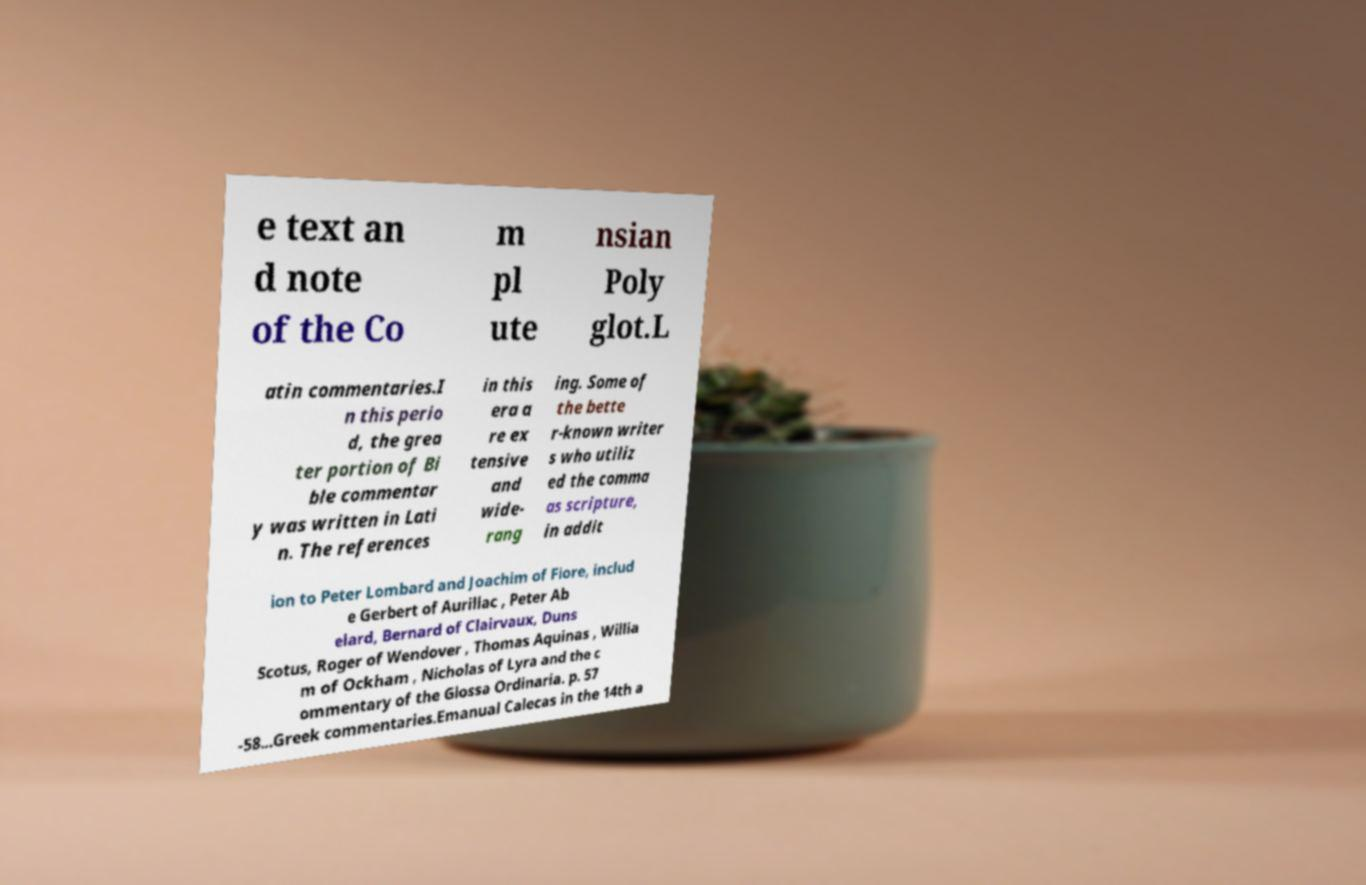Could you assist in decoding the text presented in this image and type it out clearly? e text an d note of the Co m pl ute nsian Poly glot.L atin commentaries.I n this perio d, the grea ter portion of Bi ble commentar y was written in Lati n. The references in this era a re ex tensive and wide- rang ing. Some of the bette r-known writer s who utiliz ed the comma as scripture, in addit ion to Peter Lombard and Joachim of Fiore, includ e Gerbert of Aurillac , Peter Ab elard, Bernard of Clairvaux, Duns Scotus, Roger of Wendover , Thomas Aquinas , Willia m of Ockham , Nicholas of Lyra and the c ommentary of the Glossa Ordinaria. p. 57 -58...Greek commentaries.Emanual Calecas in the 14th a 